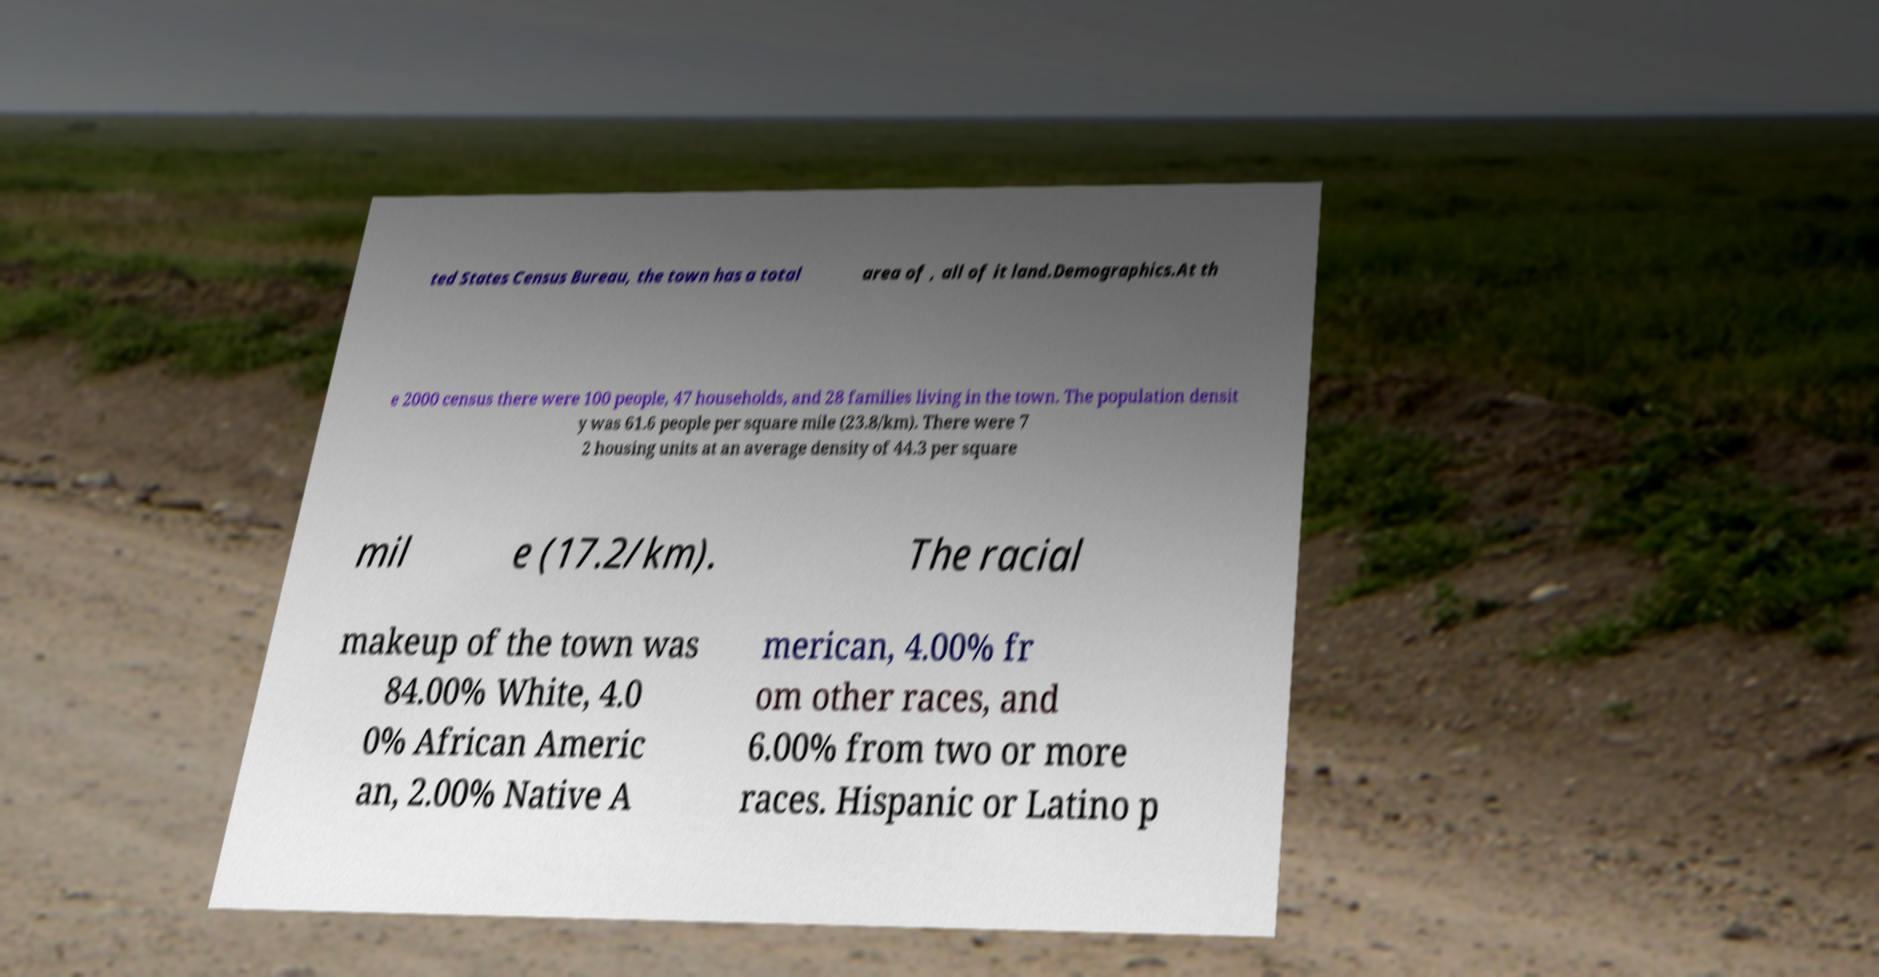Can you read and provide the text displayed in the image?This photo seems to have some interesting text. Can you extract and type it out for me? ted States Census Bureau, the town has a total area of , all of it land.Demographics.At th e 2000 census there were 100 people, 47 households, and 28 families living in the town. The population densit y was 61.6 people per square mile (23.8/km). There were 7 2 housing units at an average density of 44.3 per square mil e (17.2/km). The racial makeup of the town was 84.00% White, 4.0 0% African Americ an, 2.00% Native A merican, 4.00% fr om other races, and 6.00% from two or more races. Hispanic or Latino p 